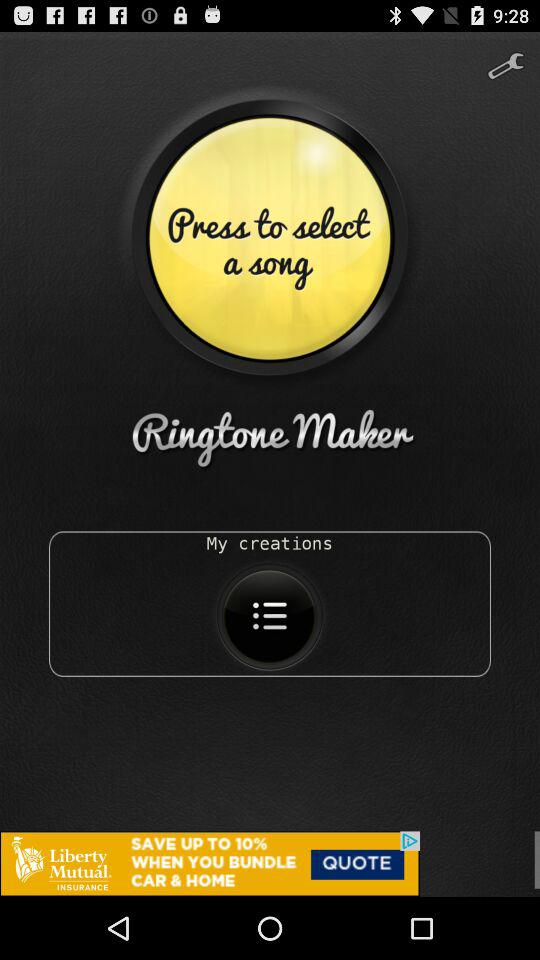What is the name of the application? The name of the application is "Ringtone Maker". 